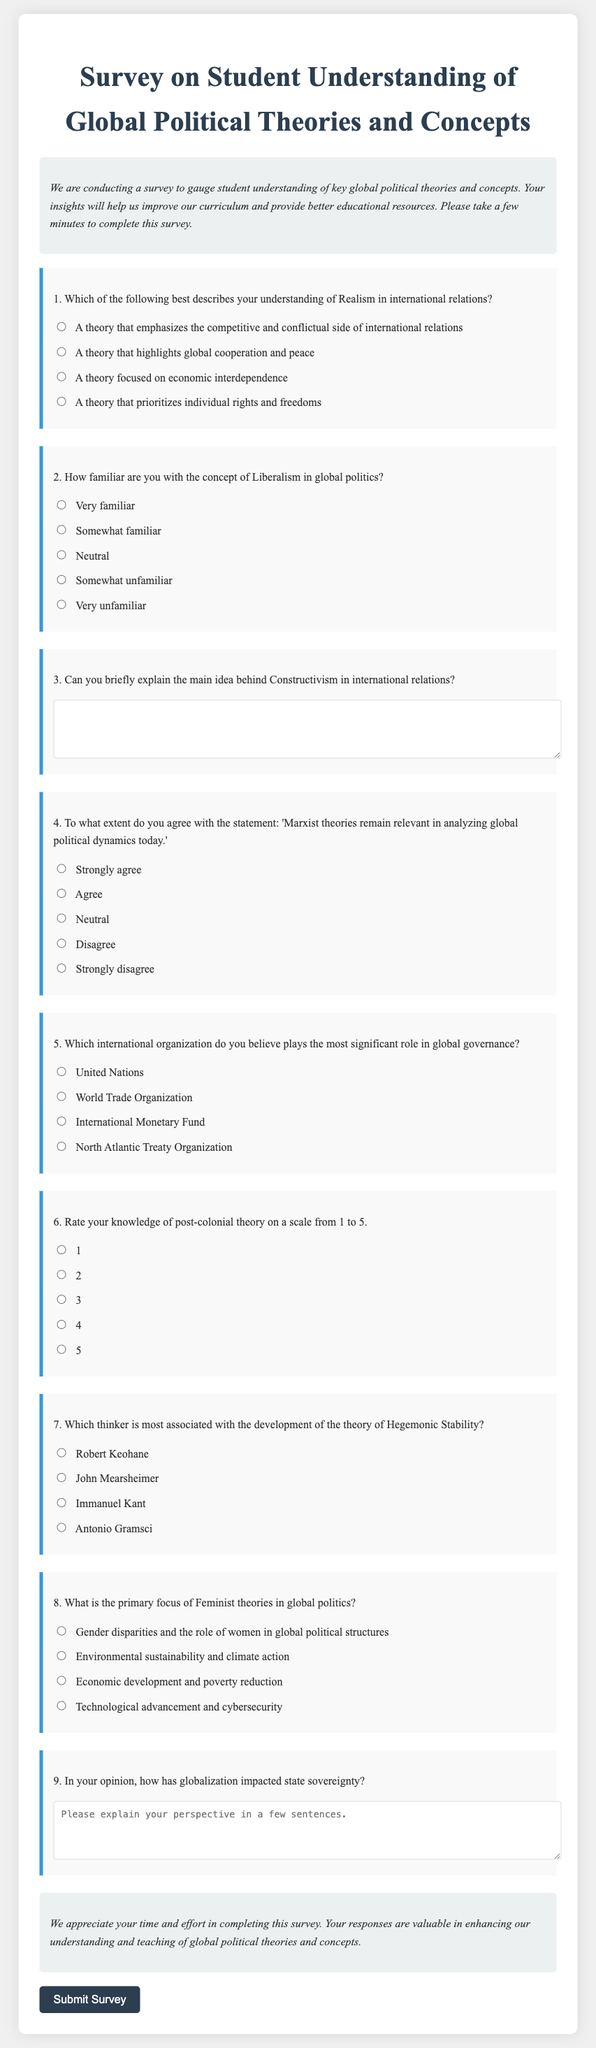What is the title of the survey? The title of the survey is indicated at the top of the document and specifies the focus of the study.
Answer: Survey on Student Understanding of Global Political Theories and Concepts How many questions are included in the survey? The document contains a total of eight multiple-choice questions, plus additional short-answer questions, which are accounted for in the overall structure.
Answer: 9 What theory does question one focus on? Question one specifically asks respondents to describe their understanding of a particular theory within the context of international relations.
Answer: Realism What type of response is required for question three? This question prompts participants to provide a brief explanation, indicating a need for open-ended short-answer responses rather than multiple-choice selections.
Answer: Brief explanation Which international organization is mentioned as playing a significant role in global governance? The document lists four international organizations, and this question seeks to identify the top organization mentioned.
Answer: United Nations How is the knowledge of post-colonial theory rated? The question asks participants to rate their knowledge on a scale from one to five, indicating varying levels of familiarity.
Answer: 1 to 5 What is the primary focus of Feminist theories in global politics? The question is designed to ascertain which key issue or area Feminist theories address specifically in the context of global politics.
Answer: Gender disparities and the role of women in global political structures What is asked in question nine regarding globalization? The survey prompts respondents to provide a personal perspective on how globalization influences state sovereignty, indicating an open discussion format.
Answer: Explain your perspective To what extent are opinions about Marxist theories solicited? This inquiry is assessed through a multiple-choice question measuring agreement or disagreement with a relevant statement regarding Marxist theories.
Answer: Level of agreement 